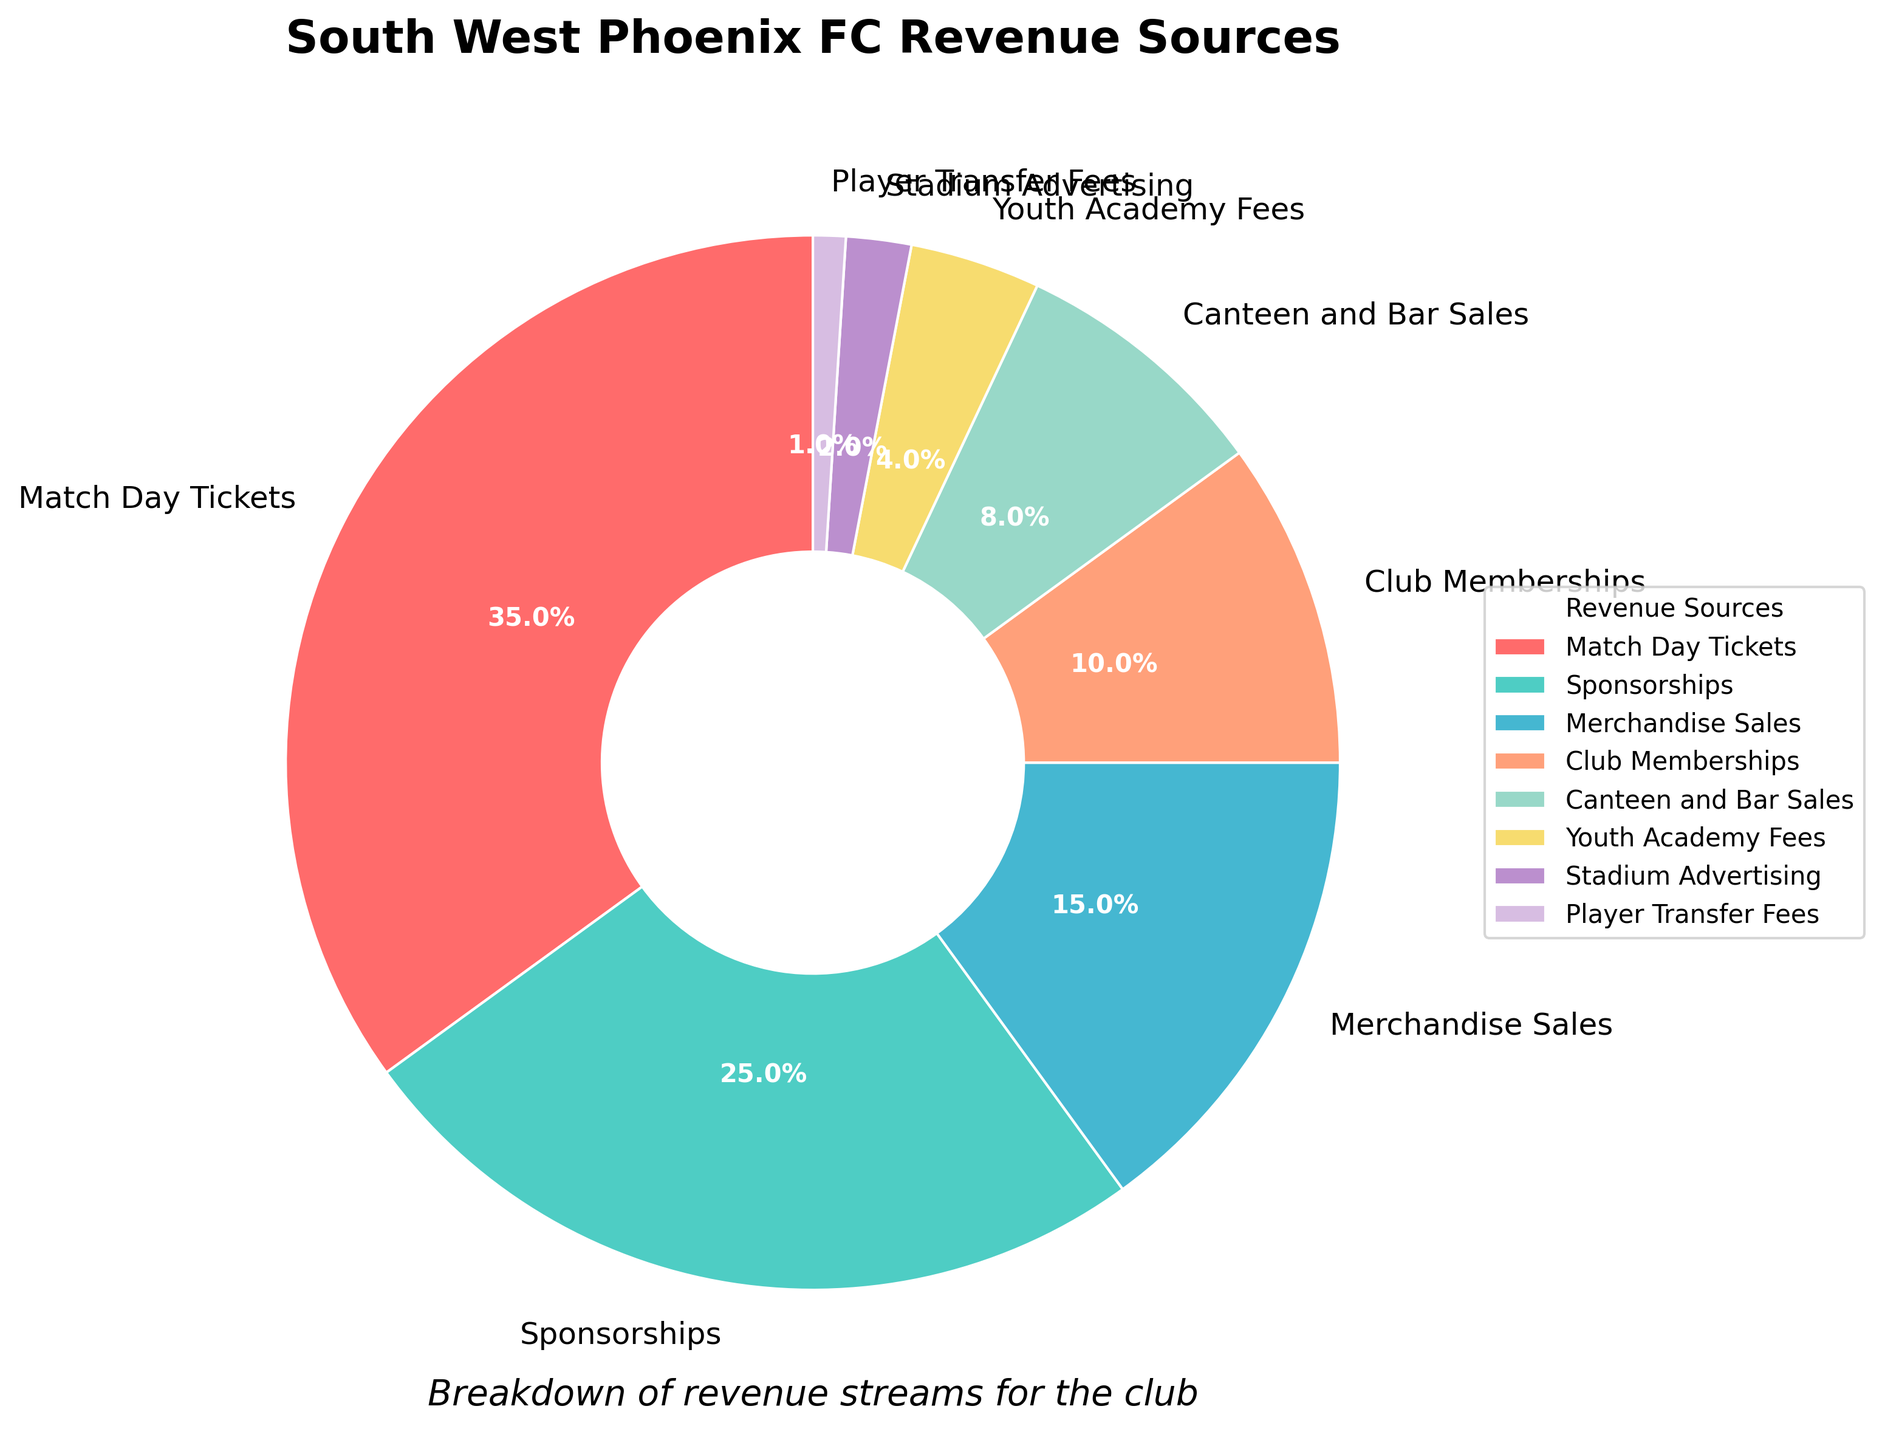Which revenue source contributes the most to South West Phoenix FC's revenue? The largest segment in the pie chart is labeled "Match Day Tickets" with a percentage of 35%, making it the highest contributor.
Answer: Match Day Tickets Which revenue source has the smallest percentage? The smallest segment is labeled "Player Transfer Fees" with a percentage of 1%, making it the smallest contributor.
Answer: Player Transfer Fees How much larger is the percentage of Match Day Tickets compared to Sponsorships? Match Day Tickets have a percentage of 35%, and Sponsorships have 25%. The difference is 35% - 25% = 10%.
Answer: 10% What is the combined percentage of Merchandise Sales, Club Memberships, and Canteen and Bar Sales? Merchandise Sales have 15%, Club Memberships have 10%, and Canteen and Bar Sales have 8%. The combined percentage is 15% + 10% + 8% = 33%.
Answer: 33% Is the percentage contribution of Youth Academy Fees greater than that of Stadium Advertising? Youth Academy Fees have a percentage of 4%, and Stadium Advertising has 2%. Since 4% > 2%, the contribution of Youth Academy Fees is greater.
Answer: Yes How many revenue sources contribute more than 10% each? The revenue sources contributing more than 10% each are Match Day Tickets (35%), Sponsorships (25%), and Merchandise Sales (15%). There are 3 such sources.
Answer: 3 What is the difference in percentage between the largest and smallest revenue sources? The largest revenue source is Match Day Tickets with 35%, and the smallest is Player Transfer Fees with 1%. The difference is 35% - 1% = 34%.
Answer: 34% Which revenue sources together contribute exactly 50% of the revenue? Sponsorships (25%) and Merchandise Sales (15%) together contribute 25% + 15% = 40%. Adding Club Memberships (10%) to this, the total becomes 50%. Hence, Sponsorships, Merchandise Sales, and Club Memberships together contribute 50%.
Answer: Sponsorships, Merchandise Sales, and Club Memberships Are there more sources contributing less than 10% or more than 10%? The sources contributing less than 10% are Club Memberships (10%), Canteen and Bar Sales (8%), Youth Academy Fees (4%), Stadium Advertising (2%), and Player Transfer Fees (1%) - totaling 5 sources. Sources contributing more than 10% are Match Day Tickets (35%), Sponsorships (25%), and Merchandise Sales (15%) - totaling 3 sources. Hence, there are more sources contributing less than 10%.
Answer: Less Which revenue sources are displayed using the color red in the pie chart? The revenue source Match Day Tickets is associated with the largest segment in red color, based on typical pie chart coloring conventions.
Answer: Match Day Tickets 